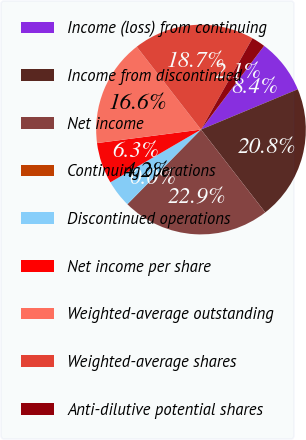Convert chart. <chart><loc_0><loc_0><loc_500><loc_500><pie_chart><fcel>Income (loss) from continuing<fcel>Income from discontinued<fcel>Net income<fcel>Continuing operations<fcel>Discontinued operations<fcel>Net income per share<fcel>Weighted-average outstanding<fcel>Weighted-average shares<fcel>Anti-dilutive potential shares<nl><fcel>8.44%<fcel>20.78%<fcel>22.89%<fcel>0.0%<fcel>4.22%<fcel>6.33%<fcel>16.56%<fcel>18.67%<fcel>2.11%<nl></chart> 